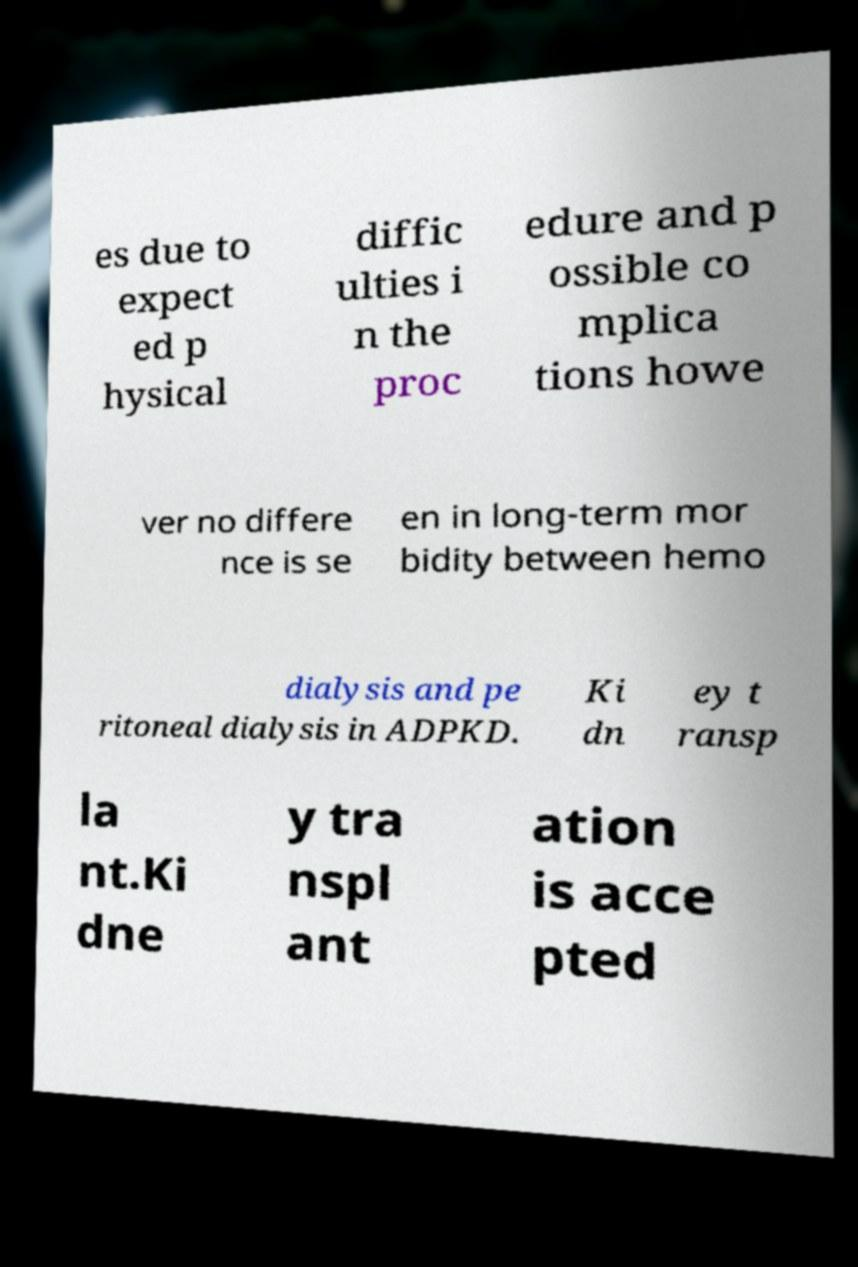For documentation purposes, I need the text within this image transcribed. Could you provide that? es due to expect ed p hysical diffic ulties i n the proc edure and p ossible co mplica tions howe ver no differe nce is se en in long-term mor bidity between hemo dialysis and pe ritoneal dialysis in ADPKD. Ki dn ey t ransp la nt.Ki dne y tra nspl ant ation is acce pted 